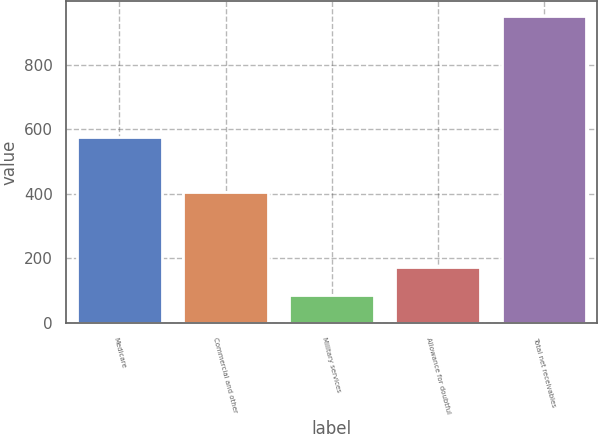<chart> <loc_0><loc_0><loc_500><loc_500><bar_chart><fcel>Medicare<fcel>Commercial and other<fcel>Military services<fcel>Allowance for doubtful<fcel>Total net receivables<nl><fcel>576<fcel>405<fcel>87<fcel>173.3<fcel>950<nl></chart> 